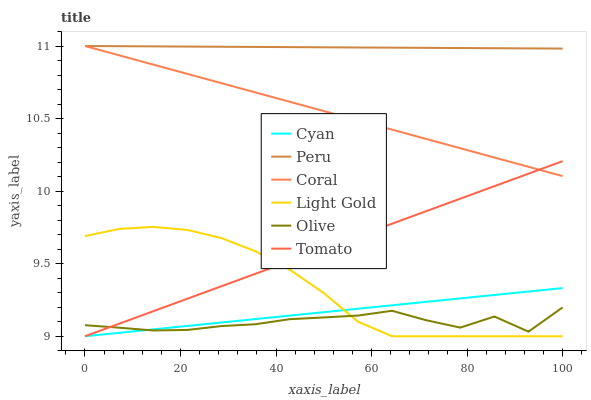Does Olive have the minimum area under the curve?
Answer yes or no. Yes. Does Peru have the maximum area under the curve?
Answer yes or no. Yes. Does Coral have the minimum area under the curve?
Answer yes or no. No. Does Coral have the maximum area under the curve?
Answer yes or no. No. Is Coral the smoothest?
Answer yes or no. Yes. Is Olive the roughest?
Answer yes or no. Yes. Is Peru the smoothest?
Answer yes or no. No. Is Peru the roughest?
Answer yes or no. No. Does Tomato have the lowest value?
Answer yes or no. Yes. Does Coral have the lowest value?
Answer yes or no. No. Does Peru have the highest value?
Answer yes or no. Yes. Does Olive have the highest value?
Answer yes or no. No. Is Olive less than Coral?
Answer yes or no. Yes. Is Peru greater than Tomato?
Answer yes or no. Yes. Does Tomato intersect Cyan?
Answer yes or no. Yes. Is Tomato less than Cyan?
Answer yes or no. No. Is Tomato greater than Cyan?
Answer yes or no. No. Does Olive intersect Coral?
Answer yes or no. No. 